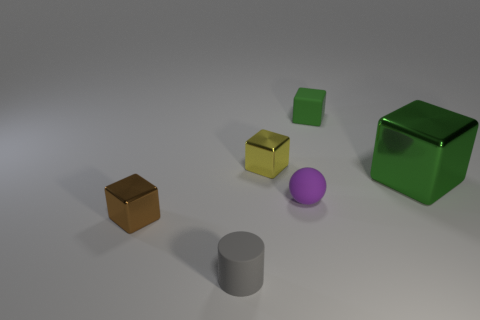Add 1 yellow things. How many objects exist? 7 Subtract all tiny yellow blocks. How many blocks are left? 3 Subtract 1 cylinders. How many cylinders are left? 0 Subtract all yellow cubes. How many cubes are left? 3 Subtract all cubes. How many objects are left? 2 Subtract all purple rubber objects. Subtract all green objects. How many objects are left? 3 Add 6 gray cylinders. How many gray cylinders are left? 7 Add 5 tiny green things. How many tiny green things exist? 6 Subtract 0 green cylinders. How many objects are left? 6 Subtract all brown spheres. Subtract all purple cylinders. How many spheres are left? 1 